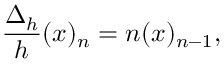Convert formula to latex. <formula><loc_0><loc_0><loc_500><loc_500>{ \frac { \Delta _ { h } } { h } } ( x ) _ { n } = n ( x ) _ { n - 1 } ,</formula> 